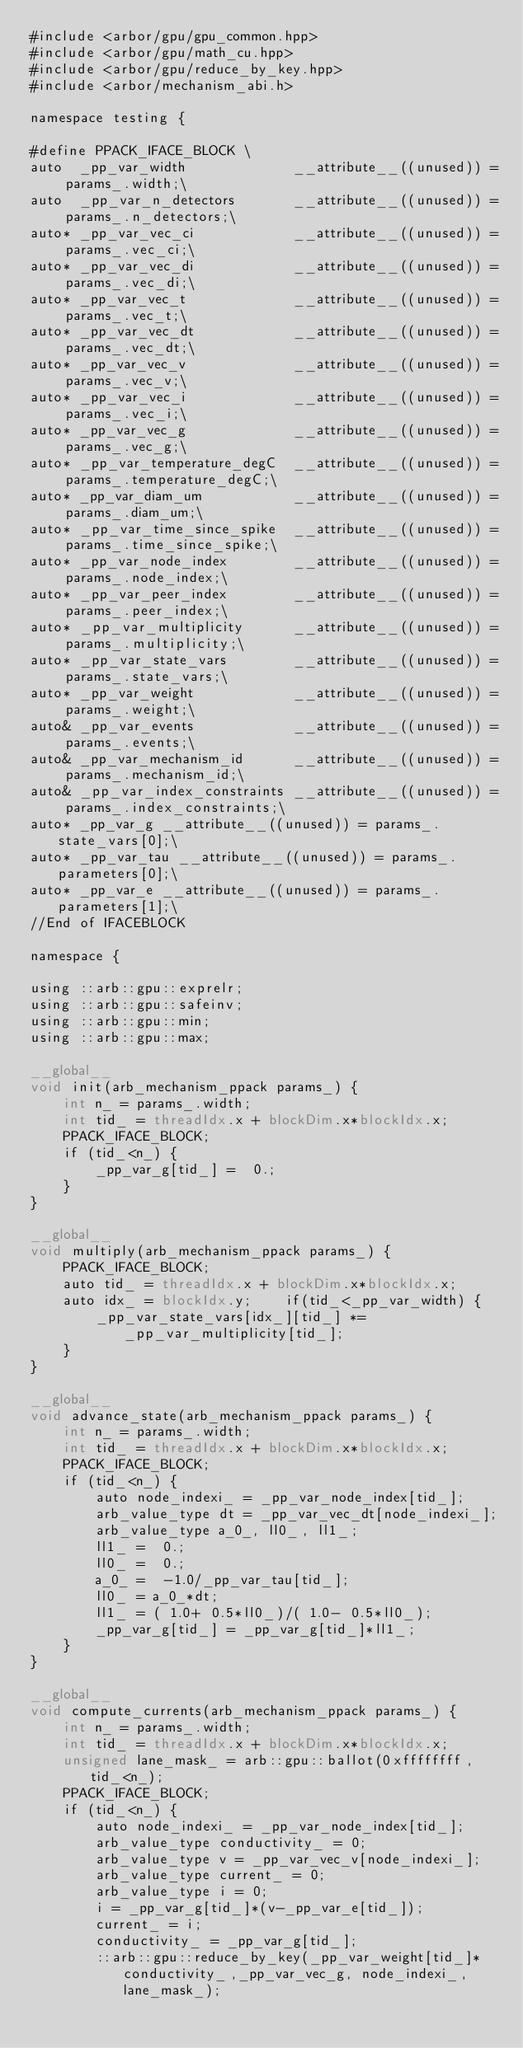<code> <loc_0><loc_0><loc_500><loc_500><_Cuda_>#include <arbor/gpu/gpu_common.hpp>
#include <arbor/gpu/math_cu.hpp>
#include <arbor/gpu/reduce_by_key.hpp>
#include <arbor/mechanism_abi.h>

namespace testing {

#define PPACK_IFACE_BLOCK \
auto  _pp_var_width             __attribute__((unused)) = params_.width;\
auto  _pp_var_n_detectors       __attribute__((unused)) = params_.n_detectors;\
auto* _pp_var_vec_ci            __attribute__((unused)) = params_.vec_ci;\
auto* _pp_var_vec_di            __attribute__((unused)) = params_.vec_di;\
auto* _pp_var_vec_t             __attribute__((unused)) = params_.vec_t;\
auto* _pp_var_vec_dt            __attribute__((unused)) = params_.vec_dt;\
auto* _pp_var_vec_v             __attribute__((unused)) = params_.vec_v;\
auto* _pp_var_vec_i             __attribute__((unused)) = params_.vec_i;\
auto* _pp_var_vec_g             __attribute__((unused)) = params_.vec_g;\
auto* _pp_var_temperature_degC  __attribute__((unused)) = params_.temperature_degC;\
auto* _pp_var_diam_um           __attribute__((unused)) = params_.diam_um;\
auto* _pp_var_time_since_spike  __attribute__((unused)) = params_.time_since_spike;\
auto* _pp_var_node_index        __attribute__((unused)) = params_.node_index;\
auto* _pp_var_peer_index        __attribute__((unused)) = params_.peer_index;\
auto* _pp_var_multiplicity      __attribute__((unused)) = params_.multiplicity;\
auto* _pp_var_state_vars        __attribute__((unused)) = params_.state_vars;\
auto* _pp_var_weight            __attribute__((unused)) = params_.weight;\
auto& _pp_var_events            __attribute__((unused)) = params_.events;\
auto& _pp_var_mechanism_id      __attribute__((unused)) = params_.mechanism_id;\
auto& _pp_var_index_constraints __attribute__((unused)) = params_.index_constraints;\
auto* _pp_var_g __attribute__((unused)) = params_.state_vars[0];\
auto* _pp_var_tau __attribute__((unused)) = params_.parameters[0];\
auto* _pp_var_e __attribute__((unused)) = params_.parameters[1];\
//End of IFACEBLOCK

namespace {

using ::arb::gpu::exprelr;
using ::arb::gpu::safeinv;
using ::arb::gpu::min;
using ::arb::gpu::max;

__global__
void init(arb_mechanism_ppack params_) {
    int n_ = params_.width;
    int tid_ = threadIdx.x + blockDim.x*blockIdx.x;
    PPACK_IFACE_BLOCK;
    if (tid_<n_) {
        _pp_var_g[tid_] =  0.;
    }
}

__global__
void multiply(arb_mechanism_ppack params_) {
    PPACK_IFACE_BLOCK;
    auto tid_ = threadIdx.x + blockDim.x*blockIdx.x;
    auto idx_ = blockIdx.y;    if(tid_<_pp_var_width) {
        _pp_var_state_vars[idx_][tid_] *= _pp_var_multiplicity[tid_];
    }
}

__global__
void advance_state(arb_mechanism_ppack params_) {
    int n_ = params_.width;
    int tid_ = threadIdx.x + blockDim.x*blockIdx.x;
    PPACK_IFACE_BLOCK;
    if (tid_<n_) {
        auto node_indexi_ = _pp_var_node_index[tid_];
        arb_value_type dt = _pp_var_vec_dt[node_indexi_];
        arb_value_type a_0_, ll0_, ll1_;
        ll1_ =  0.;
        ll0_ =  0.;
        a_0_ =  -1.0/_pp_var_tau[tid_];
        ll0_ = a_0_*dt;
        ll1_ = ( 1.0+ 0.5*ll0_)/( 1.0- 0.5*ll0_);
        _pp_var_g[tid_] = _pp_var_g[tid_]*ll1_;
    }
}

__global__
void compute_currents(arb_mechanism_ppack params_) {
    int n_ = params_.width;
    int tid_ = threadIdx.x + blockDim.x*blockIdx.x;
    unsigned lane_mask_ = arb::gpu::ballot(0xffffffff, tid_<n_);
    PPACK_IFACE_BLOCK;
    if (tid_<n_) {
        auto node_indexi_ = _pp_var_node_index[tid_];
        arb_value_type conductivity_ = 0;
        arb_value_type v = _pp_var_vec_v[node_indexi_];
        arb_value_type current_ = 0;
        arb_value_type i = 0;
        i = _pp_var_g[tid_]*(v-_pp_var_e[tid_]);
        current_ = i;
        conductivity_ = _pp_var_g[tid_];
        ::arb::gpu::reduce_by_key(_pp_var_weight[tid_]*conductivity_,_pp_var_vec_g, node_indexi_, lane_mask_);</code> 